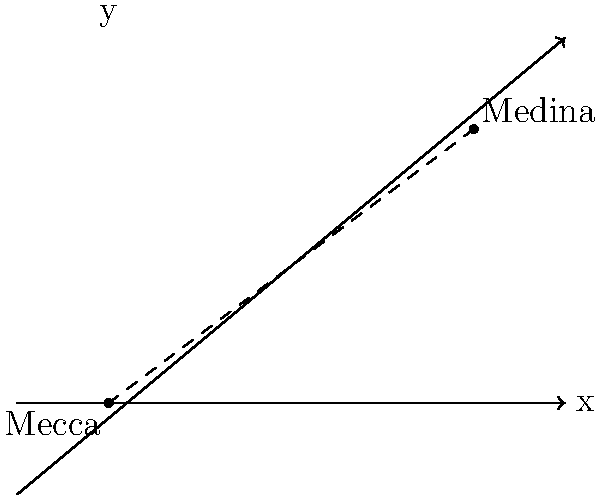During 'Umar ibn al-Khattab's caliphate, the distance between Mecca and Medina was crucial for pilgrimage routes. Using the coordinate system shown, where Mecca is at (0,0) and Medina is at (4,3), calculate the straight-line distance between these two holy cities. Round your answer to the nearest whole number. To calculate the distance between Mecca and Medina, we can use the distance formula derived from the Pythagorean theorem:

1) The distance formula is: $d = \sqrt{(x_2-x_1)^2 + (y_2-y_1)^2}$

2) We have:
   Mecca: $(x_1, y_1) = (0, 0)$
   Medina: $(x_2, y_2) = (4, 3)$

3) Plugging these into the formula:
   $d = \sqrt{(4-0)^2 + (3-0)^2}$

4) Simplify:
   $d = \sqrt{4^2 + 3^2}$
   $d = \sqrt{16 + 9}$
   $d = \sqrt{25}$

5) Calculate:
   $d = 5$

Therefore, the straight-line distance between Mecca and Medina in this coordinate system is 5 units.
Answer: 5 units 